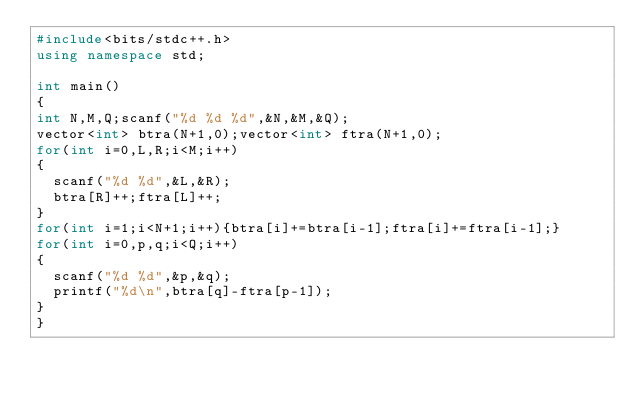<code> <loc_0><loc_0><loc_500><loc_500><_C++_>#include<bits/stdc++.h>
using namespace std;

int main()
{
int N,M,Q;scanf("%d %d %d",&N,&M,&Q);
vector<int> btra(N+1,0);vector<int> ftra(N+1,0);
for(int i=0,L,R;i<M;i++)
{
  scanf("%d %d",&L,&R);
  btra[R]++;ftra[L]++;
}
for(int i=1;i<N+1;i++){btra[i]+=btra[i-1];ftra[i]+=ftra[i-1];}
for(int i=0,p,q;i<Q;i++)
{
  scanf("%d %d",&p,&q);
  printf("%d\n",btra[q]-ftra[p-1]);
}
}</code> 